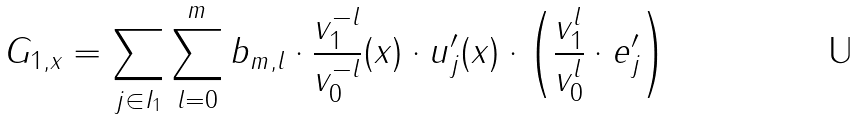Convert formula to latex. <formula><loc_0><loc_0><loc_500><loc_500>G _ { 1 , x } = \sum _ { j \in I _ { 1 } } \sum _ { l = 0 } ^ { m } b _ { m , l } \cdot \frac { v _ { 1 } ^ { - l } } { v _ { 0 } ^ { - l } } ( x ) \cdot u _ { j } ^ { \prime } ( x ) \cdot \left ( \frac { v _ { 1 } ^ { l } } { v _ { 0 } ^ { l } } \cdot e _ { j } ^ { \prime } \right )</formula> 